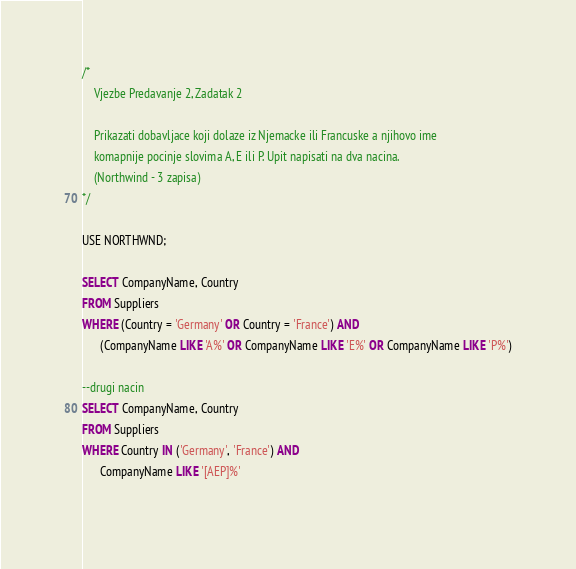<code> <loc_0><loc_0><loc_500><loc_500><_SQL_>/*
	Vjezbe Predavanje 2, Zadatak 2

	Prikazati dobavljace koji dolaze iz Njemacke ili Francuske a njihovo ime
	komapnije pocinje slovima A, E ili P. Upit napisati na dva nacina. 
	(Northwind - 3 zapisa)
*/

USE NORTHWND;

SELECT CompanyName, Country
FROM Suppliers
WHERE (Country = 'Germany' OR Country = 'France') AND
	  (CompanyName LIKE 'A%' OR CompanyName LIKE 'E%' OR CompanyName LIKE 'P%')

--drugi nacin
SELECT CompanyName, Country
FROM Suppliers
WHERE Country IN ('Germany', 'France') AND
	  CompanyName LIKE '[AEP]%'
	  </code> 